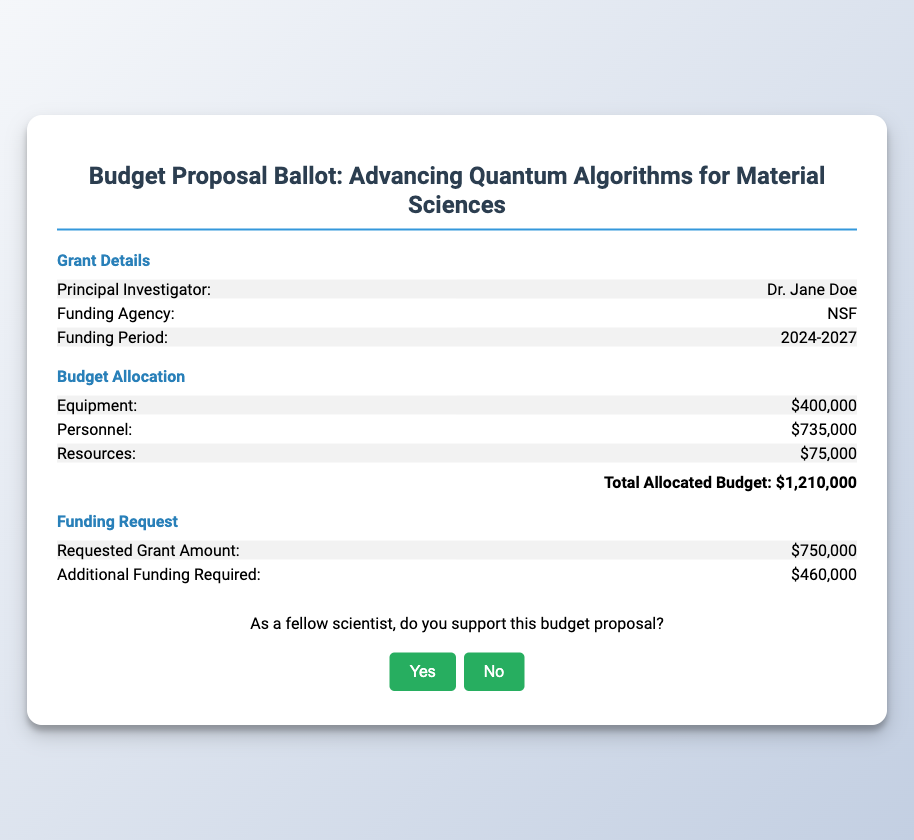What is the total allocated budget? The total allocated budget is presented in the budget allocation section, and is the sum of equipment, personnel, and resources.
Answer: $1,210,000 Who is the Principal Investigator? The Principal Investigator's name is mentioned in the grant details section.
Answer: Dr. Jane Doe What is the requested grant amount? The requested grant amount is specified in the funding request section.
Answer: $750,000 What is the funding period? The funding period for the grant is given in the grant details section.
Answer: 2024-2027 How much additional funding is required? The amount of additional funding required is listed in the funding request section.
Answer: $460,000 Which funding agency is mentioned? The funding agency is specified in the grant details section.
Answer: NSF What percentage of the total allocated budget is allocated to personnel? To find this, we calculate the proportion of the personnel budget to the total allocated budget: (735,000 / 1,210,000) * 100.
Answer: 60.83% What is the amount allocated for equipment? The allocation for equipment is explicitly stated in the budget allocation section.
Answer: $400,000 Is there a voting section included in the document? The document contains a section inviting votes regarding the support of the budget proposal.
Answer: Yes 